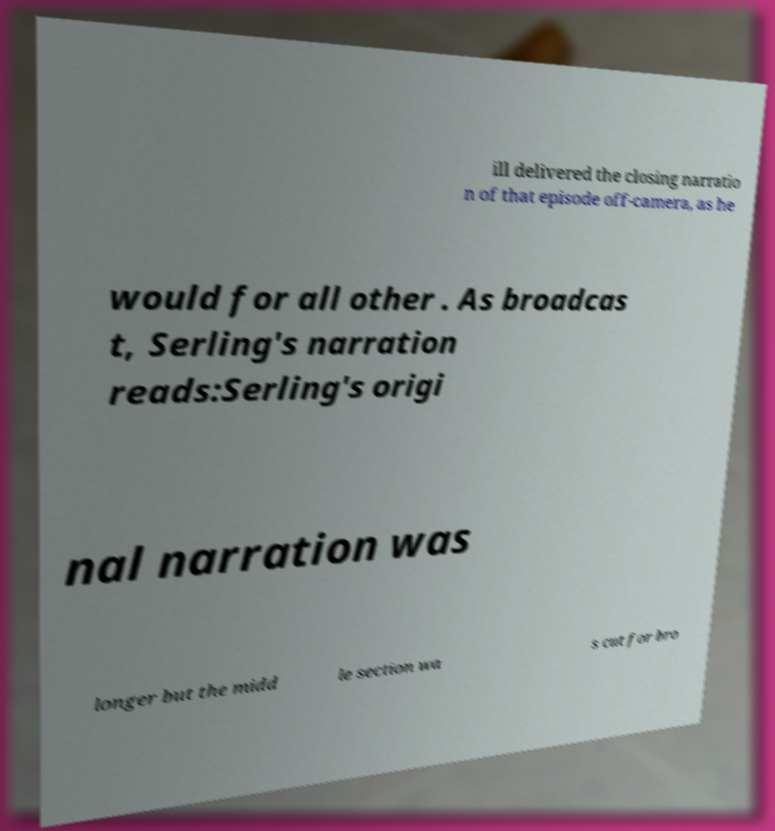For documentation purposes, I need the text within this image transcribed. Could you provide that? ill delivered the closing narratio n of that episode off-camera, as he would for all other . As broadcas t, Serling's narration reads:Serling's origi nal narration was longer but the midd le section wa s cut for bro 